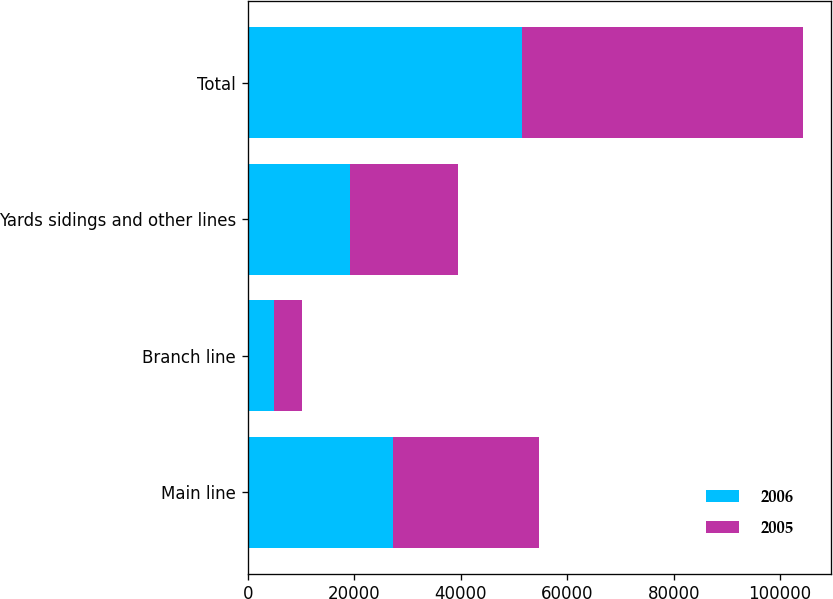<chart> <loc_0><loc_0><loc_500><loc_500><stacked_bar_chart><ecel><fcel>Main line<fcel>Branch line<fcel>Yards sidings and other lines<fcel>Total<nl><fcel>2006<fcel>27318<fcel>5021<fcel>19257<fcel>51596<nl><fcel>2005<fcel>27301<fcel>5125<fcel>20241<fcel>52667<nl></chart> 